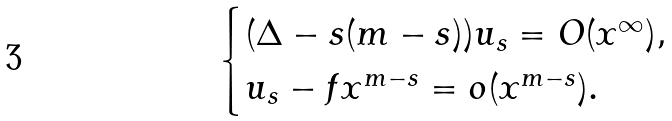<formula> <loc_0><loc_0><loc_500><loc_500>\begin{cases} ( \Delta - s ( m - s ) ) u _ { s } = O ( x ^ { \infty } ) , \\ u _ { s } - f x ^ { m - s } = o ( x ^ { m - s } ) . \end{cases}</formula> 